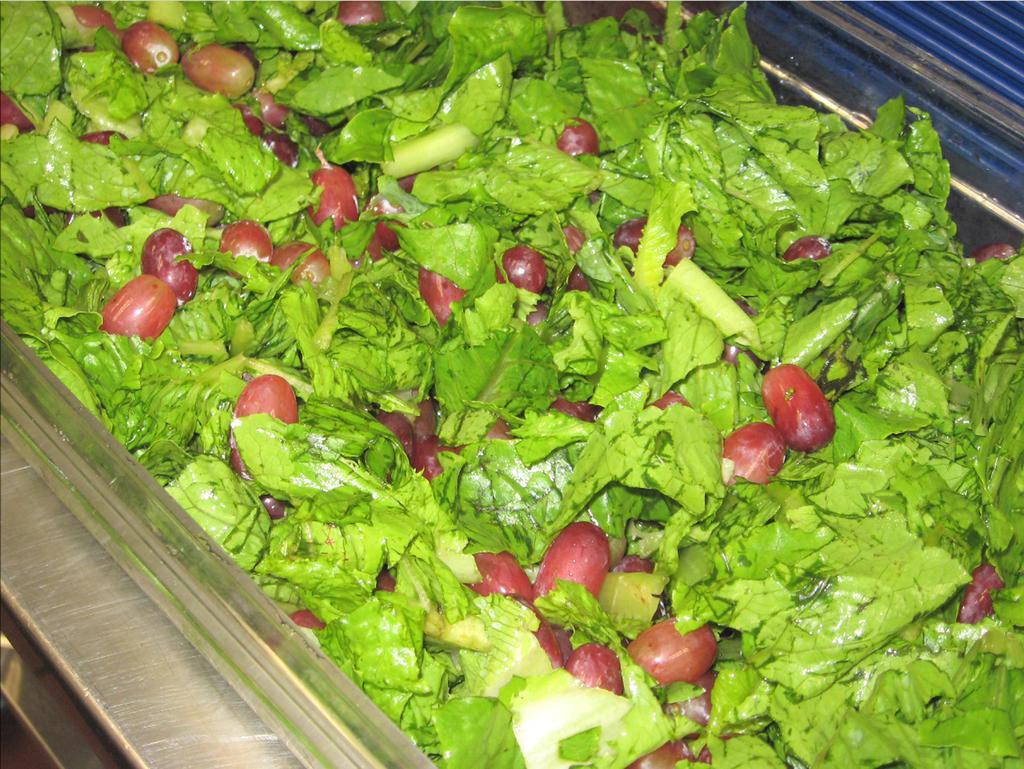Can you describe this image briefly? In the center of the image there are vegetables. 